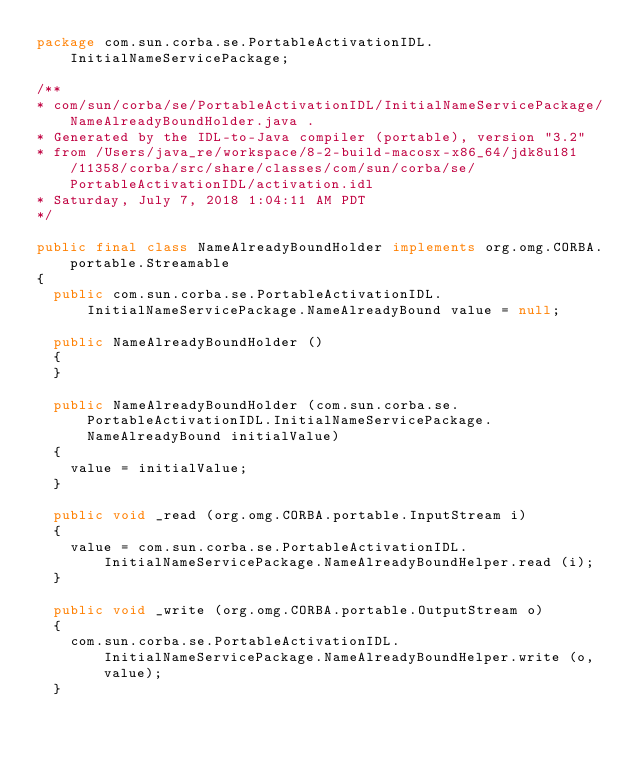<code> <loc_0><loc_0><loc_500><loc_500><_Java_>package com.sun.corba.se.PortableActivationIDL.InitialNameServicePackage;

/**
* com/sun/corba/se/PortableActivationIDL/InitialNameServicePackage/NameAlreadyBoundHolder.java .
* Generated by the IDL-to-Java compiler (portable), version "3.2"
* from /Users/java_re/workspace/8-2-build-macosx-x86_64/jdk8u181/11358/corba/src/share/classes/com/sun/corba/se/PortableActivationIDL/activation.idl
* Saturday, July 7, 2018 1:04:11 AM PDT
*/

public final class NameAlreadyBoundHolder implements org.omg.CORBA.portable.Streamable
{
  public com.sun.corba.se.PortableActivationIDL.InitialNameServicePackage.NameAlreadyBound value = null;

  public NameAlreadyBoundHolder ()
  {
  }

  public NameAlreadyBoundHolder (com.sun.corba.se.PortableActivationIDL.InitialNameServicePackage.NameAlreadyBound initialValue)
  {
    value = initialValue;
  }

  public void _read (org.omg.CORBA.portable.InputStream i)
  {
    value = com.sun.corba.se.PortableActivationIDL.InitialNameServicePackage.NameAlreadyBoundHelper.read (i);
  }

  public void _write (org.omg.CORBA.portable.OutputStream o)
  {
    com.sun.corba.se.PortableActivationIDL.InitialNameServicePackage.NameAlreadyBoundHelper.write (o, value);
  }
</code> 